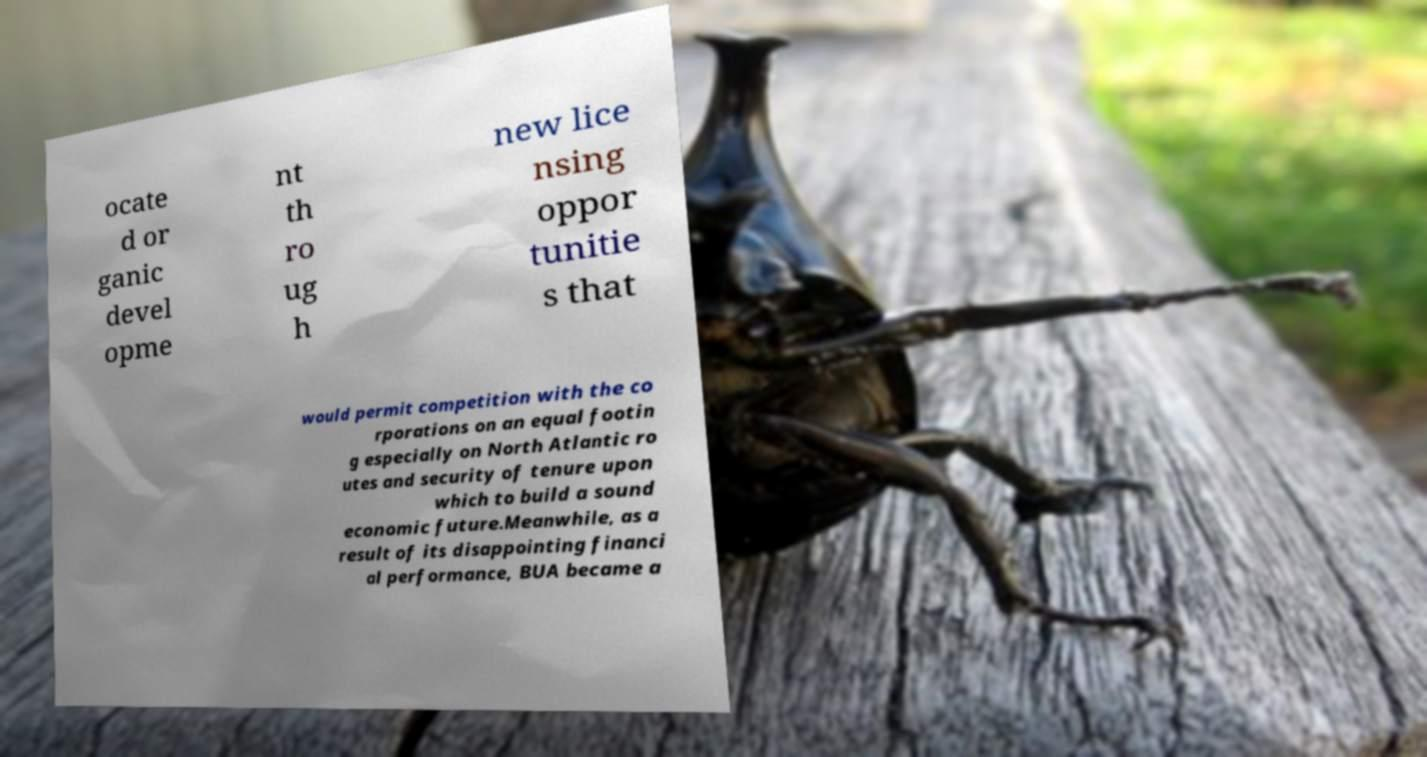Please read and relay the text visible in this image. What does it say? ocate d or ganic devel opme nt th ro ug h new lice nsing oppor tunitie s that would permit competition with the co rporations on an equal footin g especially on North Atlantic ro utes and security of tenure upon which to build a sound economic future.Meanwhile, as a result of its disappointing financi al performance, BUA became a 